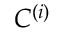<formula> <loc_0><loc_0><loc_500><loc_500>C ^ { ( i ) }</formula> 